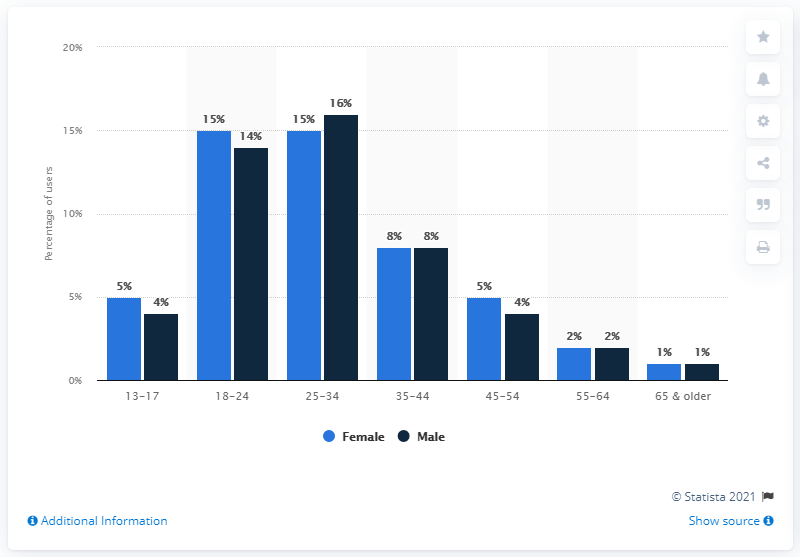Point out several critical features in this image. The difference between male and female in the age category of 25-34 years is significant. Of the categories, only three have a similar distribution of users among both male and female population. 